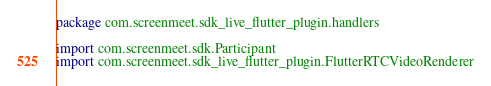Convert code to text. <code><loc_0><loc_0><loc_500><loc_500><_Kotlin_>package com.screenmeet.sdk_live_flutter_plugin.handlers

import com.screenmeet.sdk.Participant
import com.screenmeet.sdk_live_flutter_plugin.FlutterRTCVideoRenderer</code> 